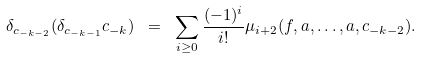Convert formula to latex. <formula><loc_0><loc_0><loc_500><loc_500>\delta _ { c _ { - k - 2 } } ( \delta _ { c _ { - k - 1 } } c _ { - k } ) \ = \ \sum _ { i \geq 0 } \frac { ( - 1 ) ^ { i } } { i ! } \mu _ { i + 2 } ( f , a , \dots , a , c _ { - k - 2 } ) .</formula> 